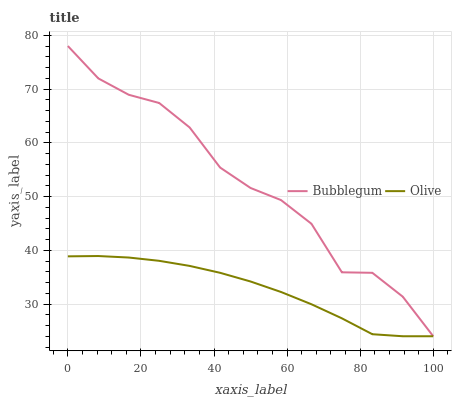Does Olive have the minimum area under the curve?
Answer yes or no. Yes. Does Bubblegum have the maximum area under the curve?
Answer yes or no. Yes. Does Bubblegum have the minimum area under the curve?
Answer yes or no. No. Is Olive the smoothest?
Answer yes or no. Yes. Is Bubblegum the roughest?
Answer yes or no. Yes. Is Bubblegum the smoothest?
Answer yes or no. No. Does Olive have the lowest value?
Answer yes or no. Yes. Does Bubblegum have the highest value?
Answer yes or no. Yes. Does Bubblegum intersect Olive?
Answer yes or no. Yes. Is Bubblegum less than Olive?
Answer yes or no. No. Is Bubblegum greater than Olive?
Answer yes or no. No. 